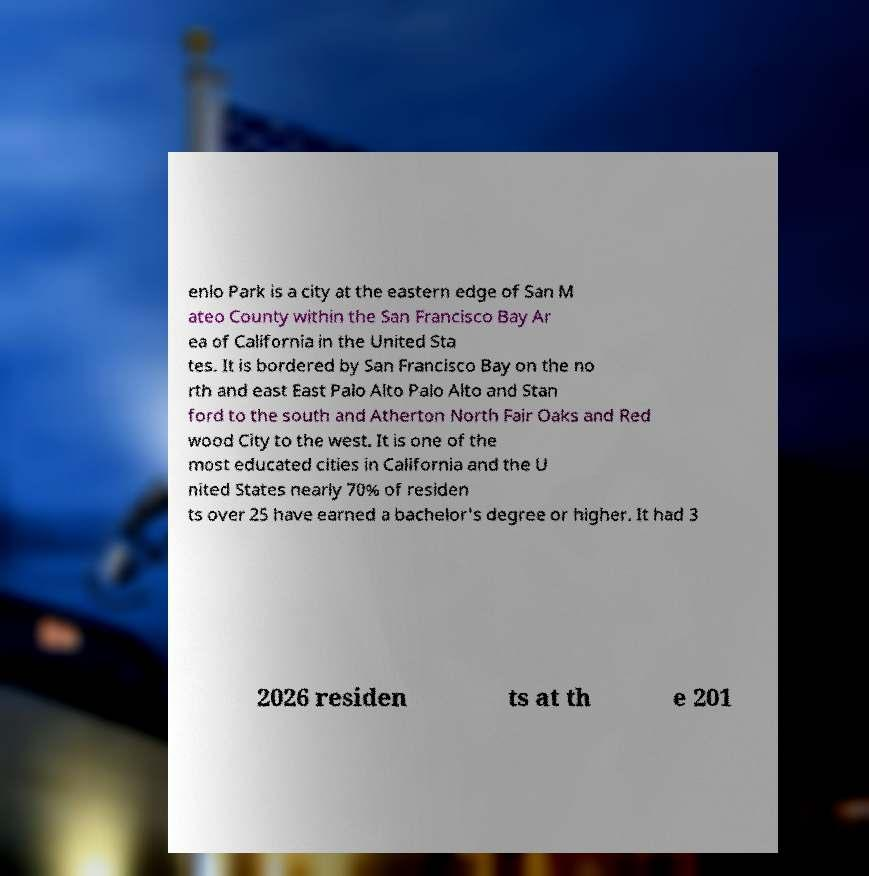Please read and relay the text visible in this image. What does it say? enlo Park is a city at the eastern edge of San M ateo County within the San Francisco Bay Ar ea of California in the United Sta tes. It is bordered by San Francisco Bay on the no rth and east East Palo Alto Palo Alto and Stan ford to the south and Atherton North Fair Oaks and Red wood City to the west. It is one of the most educated cities in California and the U nited States nearly 70% of residen ts over 25 have earned a bachelor's degree or higher. It had 3 2026 residen ts at th e 201 